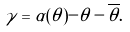Convert formula to latex. <formula><loc_0><loc_0><loc_500><loc_500>\gamma = \alpha ( \theta ) - \theta - \overline { \theta } .</formula> 